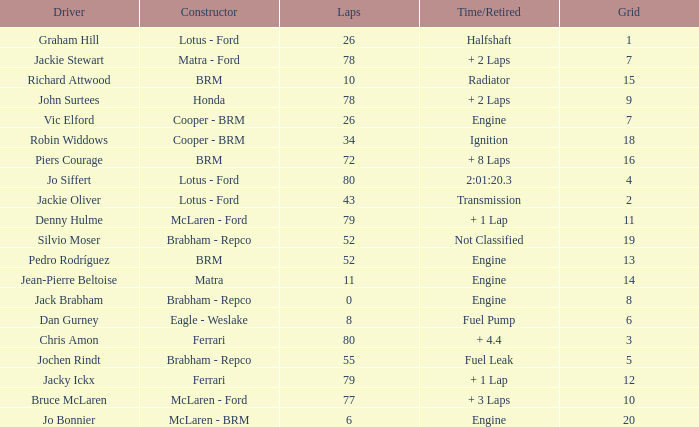When laps are less than 80 and Bruce mclaren is the driver, what is the grid? 10.0. Parse the full table. {'header': ['Driver', 'Constructor', 'Laps', 'Time/Retired', 'Grid'], 'rows': [['Graham Hill', 'Lotus - Ford', '26', 'Halfshaft', '1'], ['Jackie Stewart', 'Matra - Ford', '78', '+ 2 Laps', '7'], ['Richard Attwood', 'BRM', '10', 'Radiator', '15'], ['John Surtees', 'Honda', '78', '+ 2 Laps', '9'], ['Vic Elford', 'Cooper - BRM', '26', 'Engine', '7'], ['Robin Widdows', 'Cooper - BRM', '34', 'Ignition', '18'], ['Piers Courage', 'BRM', '72', '+ 8 Laps', '16'], ['Jo Siffert', 'Lotus - Ford', '80', '2:01:20.3', '4'], ['Jackie Oliver', 'Lotus - Ford', '43', 'Transmission', '2'], ['Denny Hulme', 'McLaren - Ford', '79', '+ 1 Lap', '11'], ['Silvio Moser', 'Brabham - Repco', '52', 'Not Classified', '19'], ['Pedro Rodríguez', 'BRM', '52', 'Engine', '13'], ['Jean-Pierre Beltoise', 'Matra', '11', 'Engine', '14'], ['Jack Brabham', 'Brabham - Repco', '0', 'Engine', '8'], ['Dan Gurney', 'Eagle - Weslake', '8', 'Fuel Pump', '6'], ['Chris Amon', 'Ferrari', '80', '+ 4.4', '3'], ['Jochen Rindt', 'Brabham - Repco', '55', 'Fuel Leak', '5'], ['Jacky Ickx', 'Ferrari', '79', '+ 1 Lap', '12'], ['Bruce McLaren', 'McLaren - Ford', '77', '+ 3 Laps', '10'], ['Jo Bonnier', 'McLaren - BRM', '6', 'Engine', '20']]} 